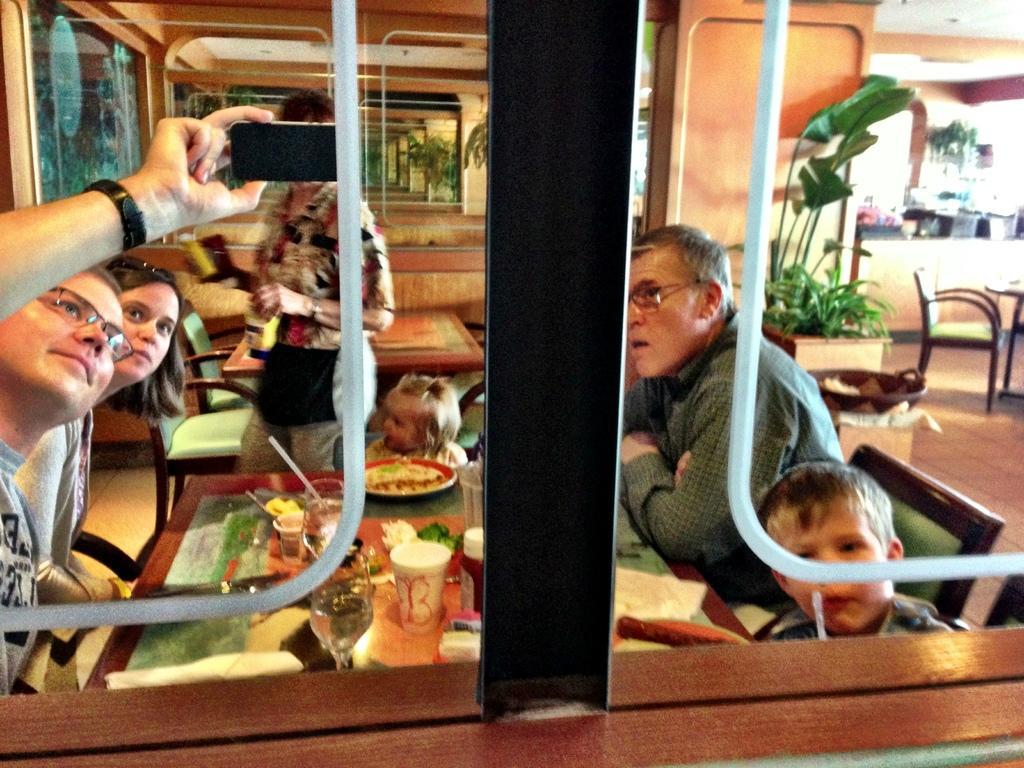Can you describe this image briefly? In the image we can see few persons. In the center we can see one woman standing and one baby sitting on the chair. On the left side we can see two persons were sitting,the man he is taking selfie. On the right side we can see two persons were sitting around the table. On table we can see some food items. And back of them we can see plant pot,tables,chairs and the few more objects. 